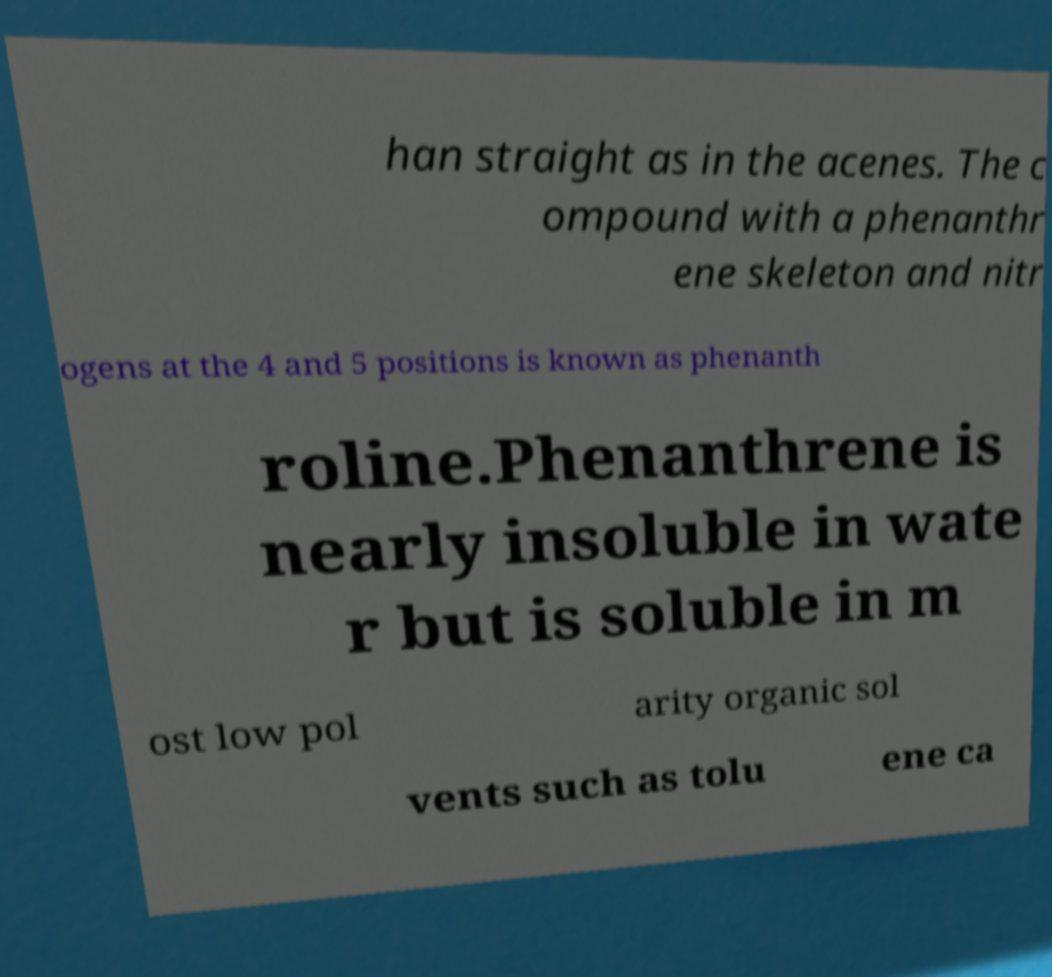For documentation purposes, I need the text within this image transcribed. Could you provide that? han straight as in the acenes. The c ompound with a phenanthr ene skeleton and nitr ogens at the 4 and 5 positions is known as phenanth roline.Phenanthrene is nearly insoluble in wate r but is soluble in m ost low pol arity organic sol vents such as tolu ene ca 